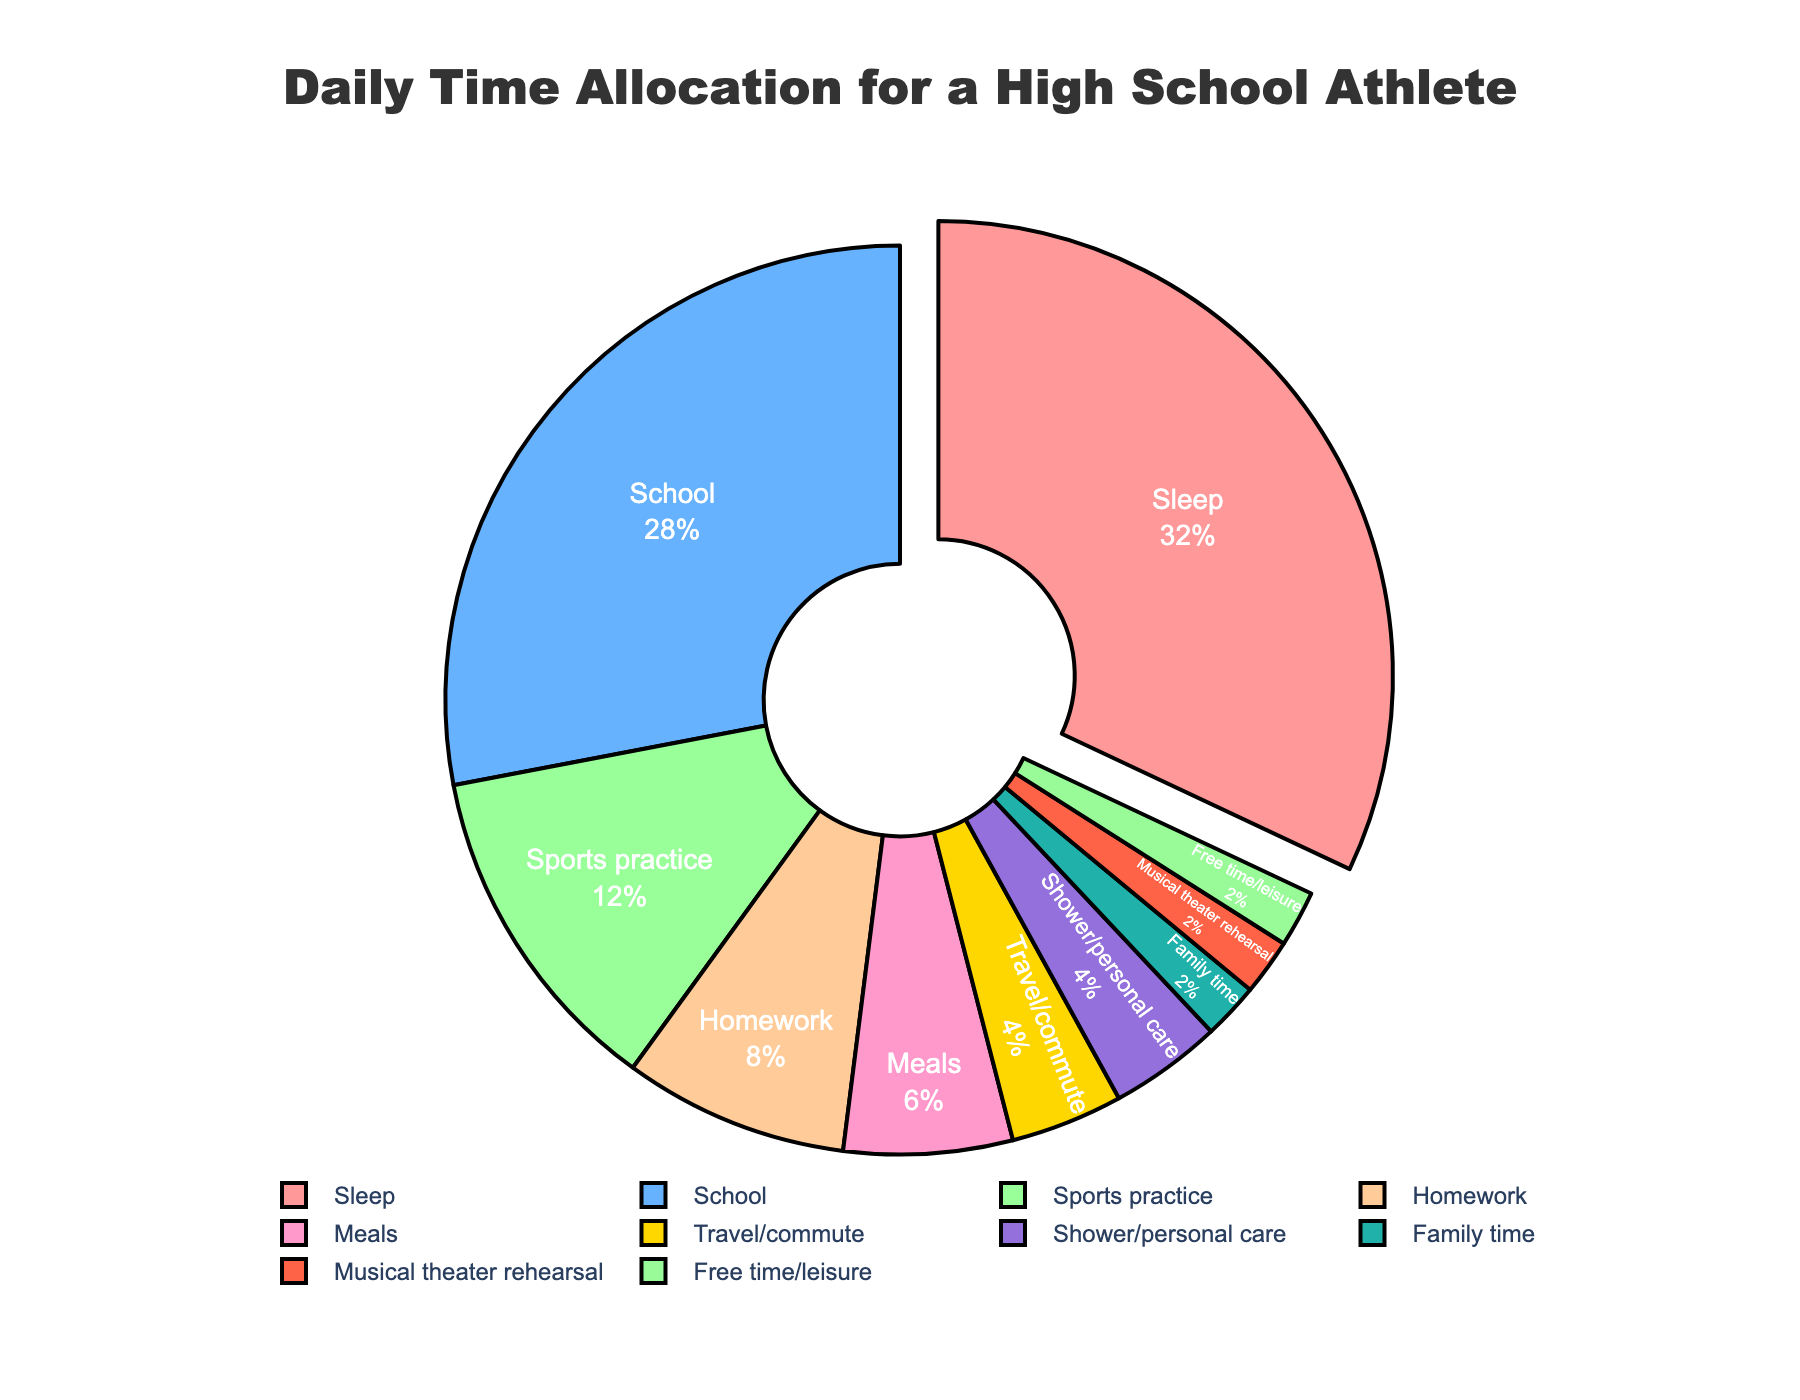What activity takes up the most time in a high school athlete's day? The largest section in the pie chart represents the activity that takes up the most time. Look for the section with the greatest percentage.
Answer: Sleep Which two activities combined take up more time than sports practice? Identify the hours allocated to sports practice (3 hours). Then, find two activities whose combined hours are greater than 3 hours. School (7) and Sleep (8) each individually exceed this, but meals (1.5) and homework (2) combined surpass 3 hours with a total of 3.5 hours.
Answer: Meals and Homework What is the total percentage of time spent on sports practice and musical theater rehearsal combined? Find the percentages of the time spent on sports practice (3 hours) and musical theater rehearsal (0.5 hours). Convert these hours to percentages and add them. Sports practice is (3/24 * 100 ≈ 12.5%) and musical theater rehearsal is (0.5/24 * 100 ≈ 2.08%). Their combined percentage is approximately 14.58%.
Answer: 14.58% How does the time spent on family time compare to the time spent on meals? Compare the hours dedicated to family time (0.5 hours) and meals (1.5 hours). Family time takes up less time than meals.
Answer: Less Which activities take up the least amount of time in the day? Identify the smallest sections on the pie chart. Activities with equal smallest values (0.5 hours each) are family time, musical theater rehearsal, and free time/leisure.
Answer: Family time, Musical theater rehearsal, and Free time/leisure How much more time is allocated to school than to musical theater rehearsal? Compare the hours allocated to school (7 hours) and musical theater rehearsal (0.5 hours). Calculate the difference: 7 hours - 0.5 hours = 6.5 hours.
Answer: 6.5 hours What fraction of the day is spent on activities other than sleep and school? Sleep and school combined take up 15 hours (8 + 7). The total number of hours in the day is 24. Subtract the time spent on sleep and school from 24: 24 - 15 = 9 hours. This is 9/24 or simplified to 3/8 of the day.
Answer: 3/8 Which activity taking more than 1 hour has the smallest allocation, and what is that activity based on its visual attribute? Identify activities that take more than 1 hour, then find the one with the smallest time: homework (2 hours), sports practice (3 hours), school (7 hours), sleep (8 hours). The smallest of these is homework.
Answer: Homework 